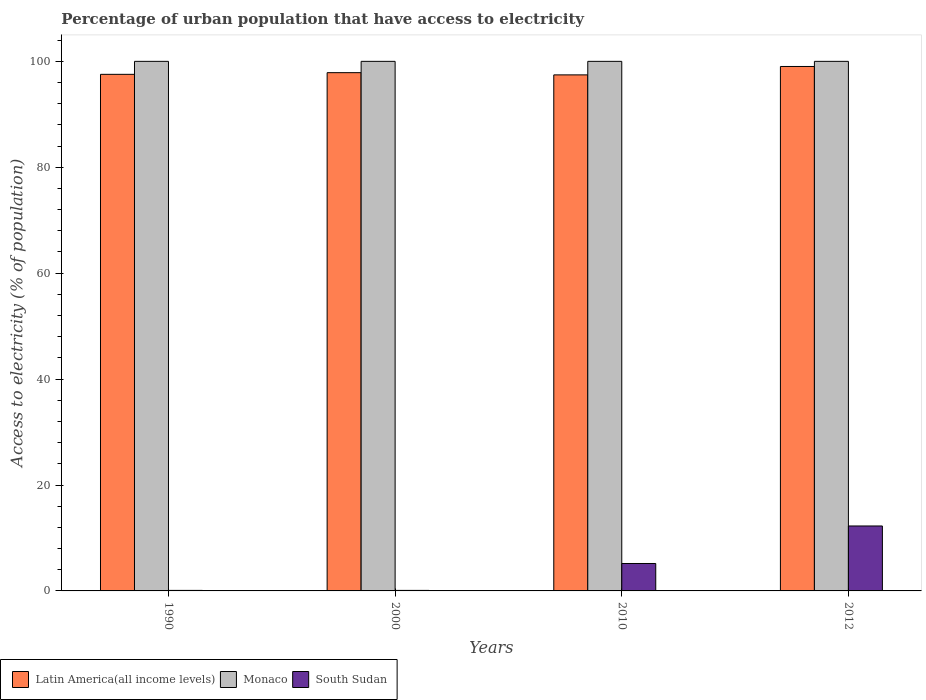How many groups of bars are there?
Make the answer very short. 4. Are the number of bars per tick equal to the number of legend labels?
Offer a very short reply. Yes. Are the number of bars on each tick of the X-axis equal?
Provide a succinct answer. Yes. How many bars are there on the 4th tick from the left?
Keep it short and to the point. 3. What is the label of the 3rd group of bars from the left?
Provide a succinct answer. 2010. What is the percentage of urban population that have access to electricity in Monaco in 2010?
Your answer should be compact. 100. Across all years, what is the maximum percentage of urban population that have access to electricity in South Sudan?
Your answer should be compact. 12.27. Across all years, what is the minimum percentage of urban population that have access to electricity in Latin America(all income levels)?
Offer a very short reply. 97.45. In which year was the percentage of urban population that have access to electricity in South Sudan maximum?
Your response must be concise. 2012. What is the total percentage of urban population that have access to electricity in Monaco in the graph?
Offer a terse response. 400. What is the difference between the percentage of urban population that have access to electricity in Latin America(all income levels) in 1990 and that in 2012?
Your answer should be compact. -1.48. What is the difference between the percentage of urban population that have access to electricity in Monaco in 2000 and the percentage of urban population that have access to electricity in South Sudan in 2012?
Your answer should be very brief. 87.73. What is the average percentage of urban population that have access to electricity in Latin America(all income levels) per year?
Your answer should be very brief. 97.97. In the year 2010, what is the difference between the percentage of urban population that have access to electricity in South Sudan and percentage of urban population that have access to electricity in Monaco?
Your answer should be very brief. -94.82. What is the ratio of the percentage of urban population that have access to electricity in Latin America(all income levels) in 2010 to that in 2012?
Your answer should be compact. 0.98. Is the percentage of urban population that have access to electricity in Latin America(all income levels) in 2000 less than that in 2010?
Make the answer very short. No. In how many years, is the percentage of urban population that have access to electricity in South Sudan greater than the average percentage of urban population that have access to electricity in South Sudan taken over all years?
Your response must be concise. 2. Is the sum of the percentage of urban population that have access to electricity in Monaco in 1990 and 2000 greater than the maximum percentage of urban population that have access to electricity in South Sudan across all years?
Ensure brevity in your answer.  Yes. What does the 1st bar from the left in 2000 represents?
Your answer should be compact. Latin America(all income levels). What does the 2nd bar from the right in 2000 represents?
Make the answer very short. Monaco. Are all the bars in the graph horizontal?
Your response must be concise. No. Are the values on the major ticks of Y-axis written in scientific E-notation?
Provide a short and direct response. No. Does the graph contain any zero values?
Ensure brevity in your answer.  No. Does the graph contain grids?
Your answer should be very brief. No. Where does the legend appear in the graph?
Your answer should be very brief. Bottom left. How many legend labels are there?
Provide a succinct answer. 3. How are the legend labels stacked?
Ensure brevity in your answer.  Horizontal. What is the title of the graph?
Your response must be concise. Percentage of urban population that have access to electricity. What is the label or title of the X-axis?
Provide a short and direct response. Years. What is the label or title of the Y-axis?
Make the answer very short. Access to electricity (% of population). What is the Access to electricity (% of population) in Latin America(all income levels) in 1990?
Your answer should be very brief. 97.55. What is the Access to electricity (% of population) of Monaco in 1990?
Your answer should be compact. 100. What is the Access to electricity (% of population) of Latin America(all income levels) in 2000?
Offer a very short reply. 97.86. What is the Access to electricity (% of population) in Latin America(all income levels) in 2010?
Make the answer very short. 97.45. What is the Access to electricity (% of population) of South Sudan in 2010?
Your answer should be very brief. 5.18. What is the Access to electricity (% of population) in Latin America(all income levels) in 2012?
Provide a succinct answer. 99.03. What is the Access to electricity (% of population) of South Sudan in 2012?
Give a very brief answer. 12.27. Across all years, what is the maximum Access to electricity (% of population) of Latin America(all income levels)?
Give a very brief answer. 99.03. Across all years, what is the maximum Access to electricity (% of population) of South Sudan?
Ensure brevity in your answer.  12.27. Across all years, what is the minimum Access to electricity (% of population) of Latin America(all income levels)?
Give a very brief answer. 97.45. Across all years, what is the minimum Access to electricity (% of population) in South Sudan?
Make the answer very short. 0.1. What is the total Access to electricity (% of population) in Latin America(all income levels) in the graph?
Offer a terse response. 391.89. What is the total Access to electricity (% of population) of Monaco in the graph?
Provide a succinct answer. 400. What is the total Access to electricity (% of population) of South Sudan in the graph?
Your answer should be very brief. 17.64. What is the difference between the Access to electricity (% of population) in Latin America(all income levels) in 1990 and that in 2000?
Provide a short and direct response. -0.32. What is the difference between the Access to electricity (% of population) of Monaco in 1990 and that in 2000?
Give a very brief answer. 0. What is the difference between the Access to electricity (% of population) of Latin America(all income levels) in 1990 and that in 2010?
Keep it short and to the point. 0.1. What is the difference between the Access to electricity (% of population) in South Sudan in 1990 and that in 2010?
Your answer should be very brief. -5.08. What is the difference between the Access to electricity (% of population) in Latin America(all income levels) in 1990 and that in 2012?
Provide a succinct answer. -1.48. What is the difference between the Access to electricity (% of population) of Monaco in 1990 and that in 2012?
Provide a succinct answer. 0. What is the difference between the Access to electricity (% of population) in South Sudan in 1990 and that in 2012?
Keep it short and to the point. -12.17. What is the difference between the Access to electricity (% of population) in Latin America(all income levels) in 2000 and that in 2010?
Provide a short and direct response. 0.42. What is the difference between the Access to electricity (% of population) in Monaco in 2000 and that in 2010?
Offer a very short reply. 0. What is the difference between the Access to electricity (% of population) of South Sudan in 2000 and that in 2010?
Offer a terse response. -5.08. What is the difference between the Access to electricity (% of population) of Latin America(all income levels) in 2000 and that in 2012?
Make the answer very short. -1.17. What is the difference between the Access to electricity (% of population) of Monaco in 2000 and that in 2012?
Your answer should be compact. 0. What is the difference between the Access to electricity (% of population) of South Sudan in 2000 and that in 2012?
Offer a very short reply. -12.17. What is the difference between the Access to electricity (% of population) of Latin America(all income levels) in 2010 and that in 2012?
Offer a terse response. -1.59. What is the difference between the Access to electricity (% of population) in Monaco in 2010 and that in 2012?
Ensure brevity in your answer.  0. What is the difference between the Access to electricity (% of population) in South Sudan in 2010 and that in 2012?
Offer a terse response. -7.09. What is the difference between the Access to electricity (% of population) of Latin America(all income levels) in 1990 and the Access to electricity (% of population) of Monaco in 2000?
Offer a very short reply. -2.45. What is the difference between the Access to electricity (% of population) in Latin America(all income levels) in 1990 and the Access to electricity (% of population) in South Sudan in 2000?
Your response must be concise. 97.45. What is the difference between the Access to electricity (% of population) of Monaco in 1990 and the Access to electricity (% of population) of South Sudan in 2000?
Give a very brief answer. 99.9. What is the difference between the Access to electricity (% of population) of Latin America(all income levels) in 1990 and the Access to electricity (% of population) of Monaco in 2010?
Offer a terse response. -2.45. What is the difference between the Access to electricity (% of population) of Latin America(all income levels) in 1990 and the Access to electricity (% of population) of South Sudan in 2010?
Your answer should be compact. 92.37. What is the difference between the Access to electricity (% of population) in Monaco in 1990 and the Access to electricity (% of population) in South Sudan in 2010?
Ensure brevity in your answer.  94.82. What is the difference between the Access to electricity (% of population) of Latin America(all income levels) in 1990 and the Access to electricity (% of population) of Monaco in 2012?
Provide a short and direct response. -2.45. What is the difference between the Access to electricity (% of population) in Latin America(all income levels) in 1990 and the Access to electricity (% of population) in South Sudan in 2012?
Give a very brief answer. 85.28. What is the difference between the Access to electricity (% of population) of Monaco in 1990 and the Access to electricity (% of population) of South Sudan in 2012?
Offer a very short reply. 87.73. What is the difference between the Access to electricity (% of population) in Latin America(all income levels) in 2000 and the Access to electricity (% of population) in Monaco in 2010?
Keep it short and to the point. -2.14. What is the difference between the Access to electricity (% of population) in Latin America(all income levels) in 2000 and the Access to electricity (% of population) in South Sudan in 2010?
Your response must be concise. 92.68. What is the difference between the Access to electricity (% of population) in Monaco in 2000 and the Access to electricity (% of population) in South Sudan in 2010?
Offer a terse response. 94.82. What is the difference between the Access to electricity (% of population) in Latin America(all income levels) in 2000 and the Access to electricity (% of population) in Monaco in 2012?
Offer a very short reply. -2.14. What is the difference between the Access to electricity (% of population) of Latin America(all income levels) in 2000 and the Access to electricity (% of population) of South Sudan in 2012?
Ensure brevity in your answer.  85.6. What is the difference between the Access to electricity (% of population) of Monaco in 2000 and the Access to electricity (% of population) of South Sudan in 2012?
Provide a short and direct response. 87.73. What is the difference between the Access to electricity (% of population) of Latin America(all income levels) in 2010 and the Access to electricity (% of population) of Monaco in 2012?
Give a very brief answer. -2.55. What is the difference between the Access to electricity (% of population) of Latin America(all income levels) in 2010 and the Access to electricity (% of population) of South Sudan in 2012?
Provide a succinct answer. 85.18. What is the difference between the Access to electricity (% of population) of Monaco in 2010 and the Access to electricity (% of population) of South Sudan in 2012?
Provide a succinct answer. 87.73. What is the average Access to electricity (% of population) of Latin America(all income levels) per year?
Your response must be concise. 97.97. What is the average Access to electricity (% of population) of Monaco per year?
Keep it short and to the point. 100. What is the average Access to electricity (% of population) in South Sudan per year?
Your response must be concise. 4.41. In the year 1990, what is the difference between the Access to electricity (% of population) of Latin America(all income levels) and Access to electricity (% of population) of Monaco?
Make the answer very short. -2.45. In the year 1990, what is the difference between the Access to electricity (% of population) of Latin America(all income levels) and Access to electricity (% of population) of South Sudan?
Provide a short and direct response. 97.45. In the year 1990, what is the difference between the Access to electricity (% of population) in Monaco and Access to electricity (% of population) in South Sudan?
Keep it short and to the point. 99.9. In the year 2000, what is the difference between the Access to electricity (% of population) in Latin America(all income levels) and Access to electricity (% of population) in Monaco?
Give a very brief answer. -2.14. In the year 2000, what is the difference between the Access to electricity (% of population) in Latin America(all income levels) and Access to electricity (% of population) in South Sudan?
Provide a succinct answer. 97.76. In the year 2000, what is the difference between the Access to electricity (% of population) of Monaco and Access to electricity (% of population) of South Sudan?
Make the answer very short. 99.9. In the year 2010, what is the difference between the Access to electricity (% of population) of Latin America(all income levels) and Access to electricity (% of population) of Monaco?
Give a very brief answer. -2.55. In the year 2010, what is the difference between the Access to electricity (% of population) of Latin America(all income levels) and Access to electricity (% of population) of South Sudan?
Offer a very short reply. 92.27. In the year 2010, what is the difference between the Access to electricity (% of population) in Monaco and Access to electricity (% of population) in South Sudan?
Offer a very short reply. 94.82. In the year 2012, what is the difference between the Access to electricity (% of population) of Latin America(all income levels) and Access to electricity (% of population) of Monaco?
Offer a very short reply. -0.97. In the year 2012, what is the difference between the Access to electricity (% of population) in Latin America(all income levels) and Access to electricity (% of population) in South Sudan?
Ensure brevity in your answer.  86.77. In the year 2012, what is the difference between the Access to electricity (% of population) in Monaco and Access to electricity (% of population) in South Sudan?
Keep it short and to the point. 87.73. What is the ratio of the Access to electricity (% of population) in Latin America(all income levels) in 1990 to that in 2000?
Provide a succinct answer. 1. What is the ratio of the Access to electricity (% of population) in Latin America(all income levels) in 1990 to that in 2010?
Keep it short and to the point. 1. What is the ratio of the Access to electricity (% of population) of South Sudan in 1990 to that in 2010?
Offer a terse response. 0.02. What is the ratio of the Access to electricity (% of population) of Latin America(all income levels) in 1990 to that in 2012?
Provide a short and direct response. 0.98. What is the ratio of the Access to electricity (% of population) in Monaco in 1990 to that in 2012?
Your answer should be very brief. 1. What is the ratio of the Access to electricity (% of population) in South Sudan in 1990 to that in 2012?
Offer a very short reply. 0.01. What is the ratio of the Access to electricity (% of population) in Latin America(all income levels) in 2000 to that in 2010?
Offer a terse response. 1. What is the ratio of the Access to electricity (% of population) of South Sudan in 2000 to that in 2010?
Offer a very short reply. 0.02. What is the ratio of the Access to electricity (% of population) of Latin America(all income levels) in 2000 to that in 2012?
Your response must be concise. 0.99. What is the ratio of the Access to electricity (% of population) of Monaco in 2000 to that in 2012?
Give a very brief answer. 1. What is the ratio of the Access to electricity (% of population) in South Sudan in 2000 to that in 2012?
Give a very brief answer. 0.01. What is the ratio of the Access to electricity (% of population) in Latin America(all income levels) in 2010 to that in 2012?
Your answer should be compact. 0.98. What is the ratio of the Access to electricity (% of population) of Monaco in 2010 to that in 2012?
Keep it short and to the point. 1. What is the ratio of the Access to electricity (% of population) of South Sudan in 2010 to that in 2012?
Give a very brief answer. 0.42. What is the difference between the highest and the second highest Access to electricity (% of population) in Latin America(all income levels)?
Offer a very short reply. 1.17. What is the difference between the highest and the second highest Access to electricity (% of population) of South Sudan?
Offer a terse response. 7.09. What is the difference between the highest and the lowest Access to electricity (% of population) in Latin America(all income levels)?
Offer a terse response. 1.59. What is the difference between the highest and the lowest Access to electricity (% of population) in Monaco?
Provide a short and direct response. 0. What is the difference between the highest and the lowest Access to electricity (% of population) in South Sudan?
Make the answer very short. 12.17. 